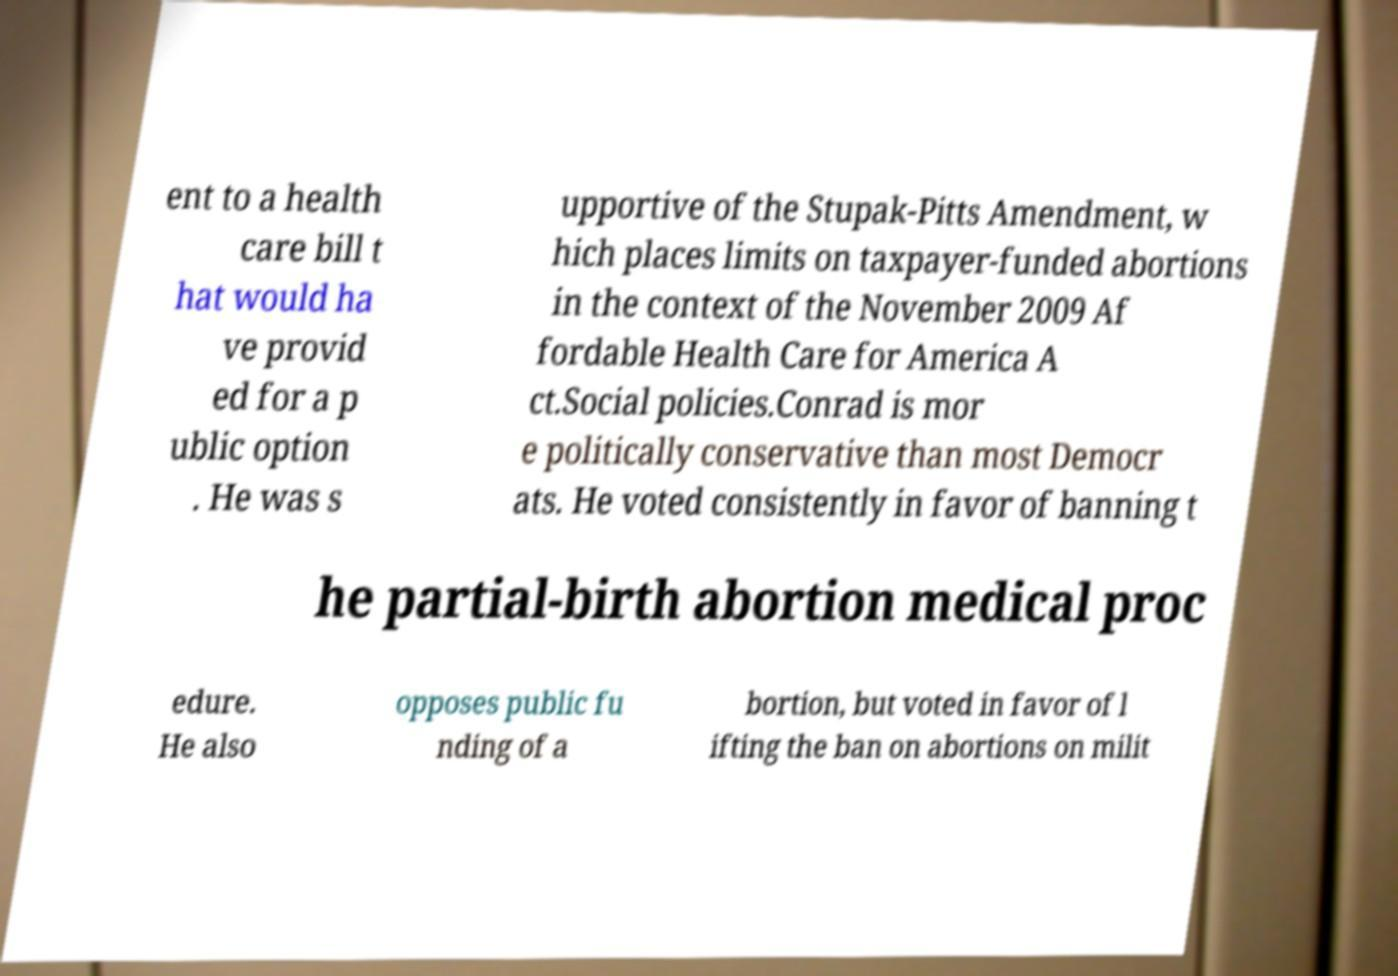Please read and relay the text visible in this image. What does it say? ent to a health care bill t hat would ha ve provid ed for a p ublic option . He was s upportive of the Stupak-Pitts Amendment, w hich places limits on taxpayer-funded abortions in the context of the November 2009 Af fordable Health Care for America A ct.Social policies.Conrad is mor e politically conservative than most Democr ats. He voted consistently in favor of banning t he partial-birth abortion medical proc edure. He also opposes public fu nding of a bortion, but voted in favor of l ifting the ban on abortions on milit 